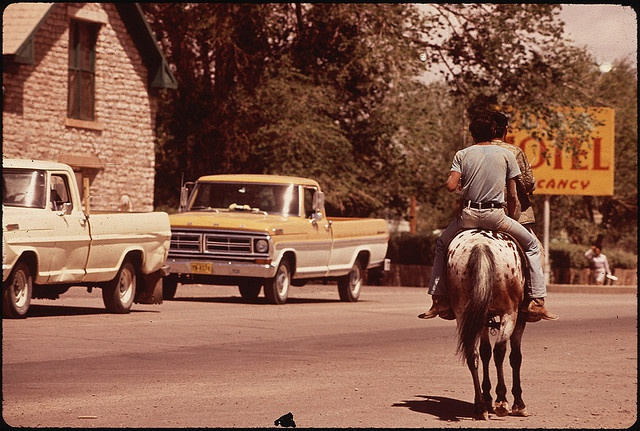Describe the objects in this image and their specific colors. I can see truck in black, tan, brown, and maroon tones, truck in black, tan, brown, and beige tones, horse in black, maroon, brown, and tan tones, people in black, maroon, brown, and tan tones, and people in black, maroon, brown, and tan tones in this image. 